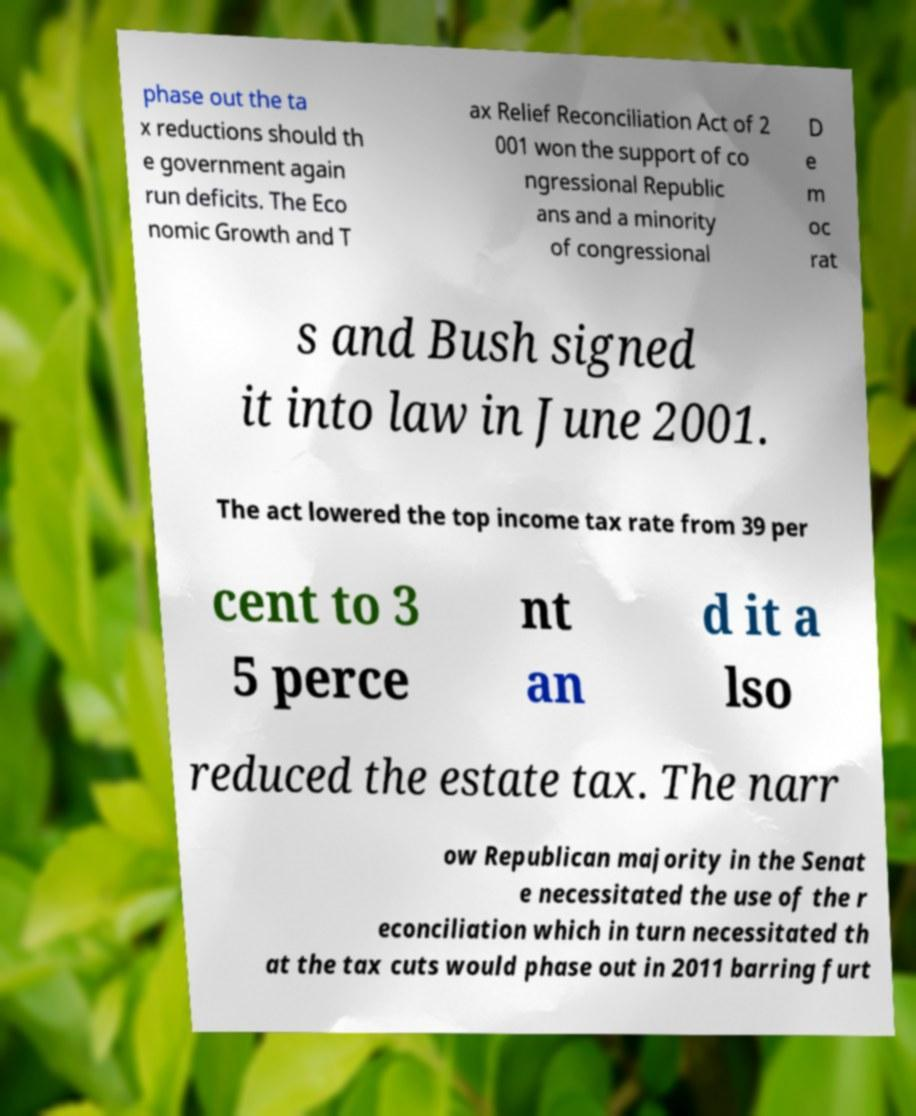What messages or text are displayed in this image? I need them in a readable, typed format. phase out the ta x reductions should th e government again run deficits. The Eco nomic Growth and T ax Relief Reconciliation Act of 2 001 won the support of co ngressional Republic ans and a minority of congressional D e m oc rat s and Bush signed it into law in June 2001. The act lowered the top income tax rate from 39 per cent to 3 5 perce nt an d it a lso reduced the estate tax. The narr ow Republican majority in the Senat e necessitated the use of the r econciliation which in turn necessitated th at the tax cuts would phase out in 2011 barring furt 